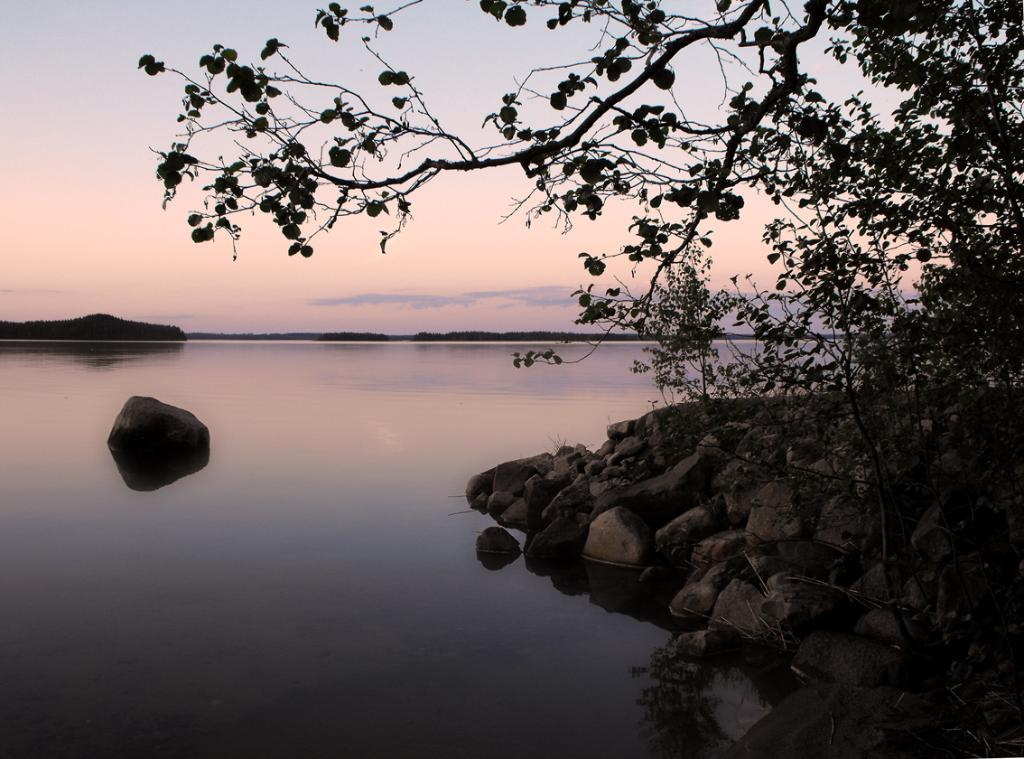What type of natural elements can be seen on the right side of the image? There are stones and trees on the right side of the image. What is visible in the background of the image? Water and clouds in the sky are visible in the background of the image. What type of relation can be seen between the stones and the cup in the image? There is no cup present in the image, so there is no relation between the stones and a cup. 